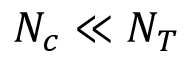Convert formula to latex. <formula><loc_0><loc_0><loc_500><loc_500>N _ { c } \ll N _ { T }</formula> 